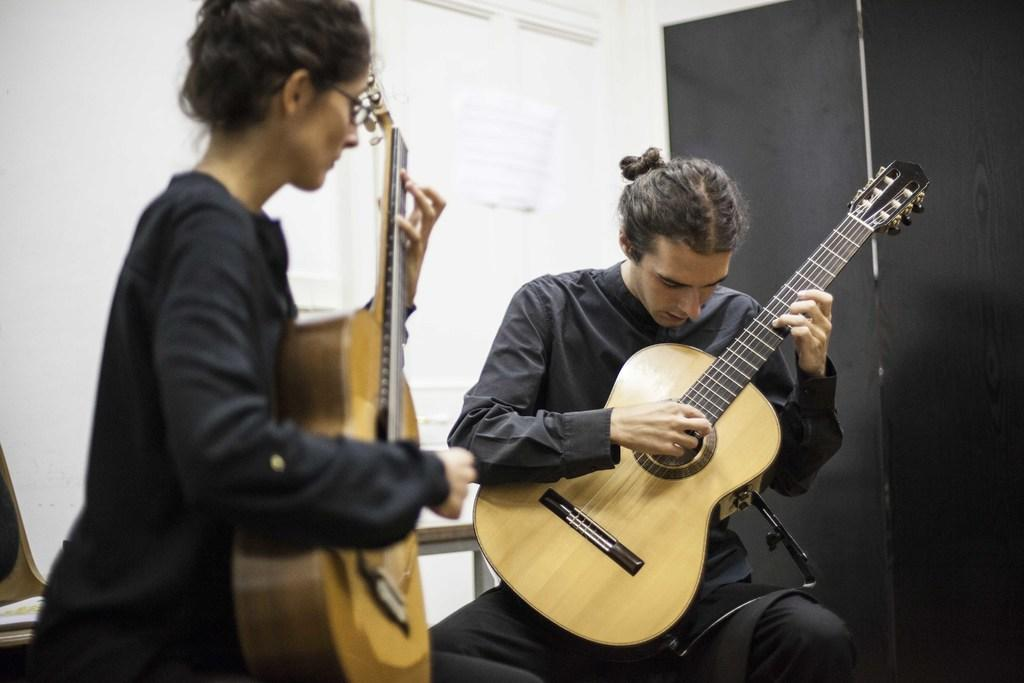How many people are in the image? There are two persons in the image. What are the two persons doing in the image? The two persons are playing a guitar. What can be seen on the right side of the image? There are black color curtains on the right side of the image. What is the color of the wall in the background of the image? There is a white color wall in the background of the image. What is the zephyr's role in the image? There is no zephyr present in the image. How does the expansion affect the guitar playing in the image? There is no expansion mentioned in the image, and it does not affect the guitar playing. 